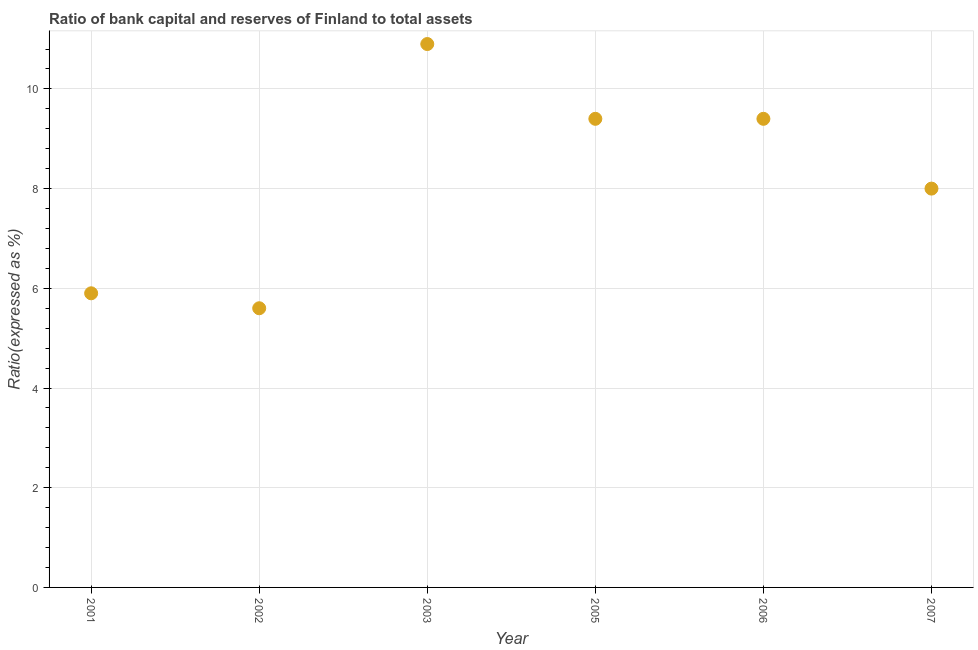Across all years, what is the maximum bank capital to assets ratio?
Provide a short and direct response. 10.9. In which year was the bank capital to assets ratio maximum?
Your answer should be very brief. 2003. What is the sum of the bank capital to assets ratio?
Keep it short and to the point. 49.2. What is the difference between the bank capital to assets ratio in 2003 and 2005?
Keep it short and to the point. 1.5. Do a majority of the years between 2007 and 2003 (inclusive) have bank capital to assets ratio greater than 4.8 %?
Your answer should be compact. Yes. What is the ratio of the bank capital to assets ratio in 2001 to that in 2005?
Ensure brevity in your answer.  0.63. Is the difference between the bank capital to assets ratio in 2001 and 2005 greater than the difference between any two years?
Your answer should be compact. No. What is the difference between the highest and the second highest bank capital to assets ratio?
Offer a very short reply. 1.5. Is the sum of the bank capital to assets ratio in 2003 and 2007 greater than the maximum bank capital to assets ratio across all years?
Provide a short and direct response. Yes. What is the difference between the highest and the lowest bank capital to assets ratio?
Provide a short and direct response. 5.3. How many years are there in the graph?
Give a very brief answer. 6. What is the difference between two consecutive major ticks on the Y-axis?
Keep it short and to the point. 2. Does the graph contain any zero values?
Your response must be concise. No. Does the graph contain grids?
Make the answer very short. Yes. What is the title of the graph?
Give a very brief answer. Ratio of bank capital and reserves of Finland to total assets. What is the label or title of the Y-axis?
Provide a short and direct response. Ratio(expressed as %). What is the Ratio(expressed as %) in 2005?
Offer a terse response. 9.4. What is the Ratio(expressed as %) in 2006?
Provide a succinct answer. 9.4. What is the Ratio(expressed as %) in 2007?
Your answer should be compact. 8. What is the difference between the Ratio(expressed as %) in 2001 and 2006?
Your answer should be compact. -3.5. What is the difference between the Ratio(expressed as %) in 2002 and 2003?
Make the answer very short. -5.3. What is the difference between the Ratio(expressed as %) in 2002 and 2005?
Your answer should be compact. -3.8. What is the difference between the Ratio(expressed as %) in 2002 and 2006?
Provide a short and direct response. -3.8. What is the difference between the Ratio(expressed as %) in 2003 and 2006?
Offer a very short reply. 1.5. What is the difference between the Ratio(expressed as %) in 2005 and 2006?
Your answer should be very brief. 0. What is the difference between the Ratio(expressed as %) in 2005 and 2007?
Provide a short and direct response. 1.4. What is the ratio of the Ratio(expressed as %) in 2001 to that in 2002?
Keep it short and to the point. 1.05. What is the ratio of the Ratio(expressed as %) in 2001 to that in 2003?
Offer a very short reply. 0.54. What is the ratio of the Ratio(expressed as %) in 2001 to that in 2005?
Ensure brevity in your answer.  0.63. What is the ratio of the Ratio(expressed as %) in 2001 to that in 2006?
Keep it short and to the point. 0.63. What is the ratio of the Ratio(expressed as %) in 2001 to that in 2007?
Your response must be concise. 0.74. What is the ratio of the Ratio(expressed as %) in 2002 to that in 2003?
Offer a terse response. 0.51. What is the ratio of the Ratio(expressed as %) in 2002 to that in 2005?
Your answer should be compact. 0.6. What is the ratio of the Ratio(expressed as %) in 2002 to that in 2006?
Your response must be concise. 0.6. What is the ratio of the Ratio(expressed as %) in 2003 to that in 2005?
Provide a short and direct response. 1.16. What is the ratio of the Ratio(expressed as %) in 2003 to that in 2006?
Ensure brevity in your answer.  1.16. What is the ratio of the Ratio(expressed as %) in 2003 to that in 2007?
Keep it short and to the point. 1.36. What is the ratio of the Ratio(expressed as %) in 2005 to that in 2006?
Offer a terse response. 1. What is the ratio of the Ratio(expressed as %) in 2005 to that in 2007?
Offer a terse response. 1.18. What is the ratio of the Ratio(expressed as %) in 2006 to that in 2007?
Provide a succinct answer. 1.18. 